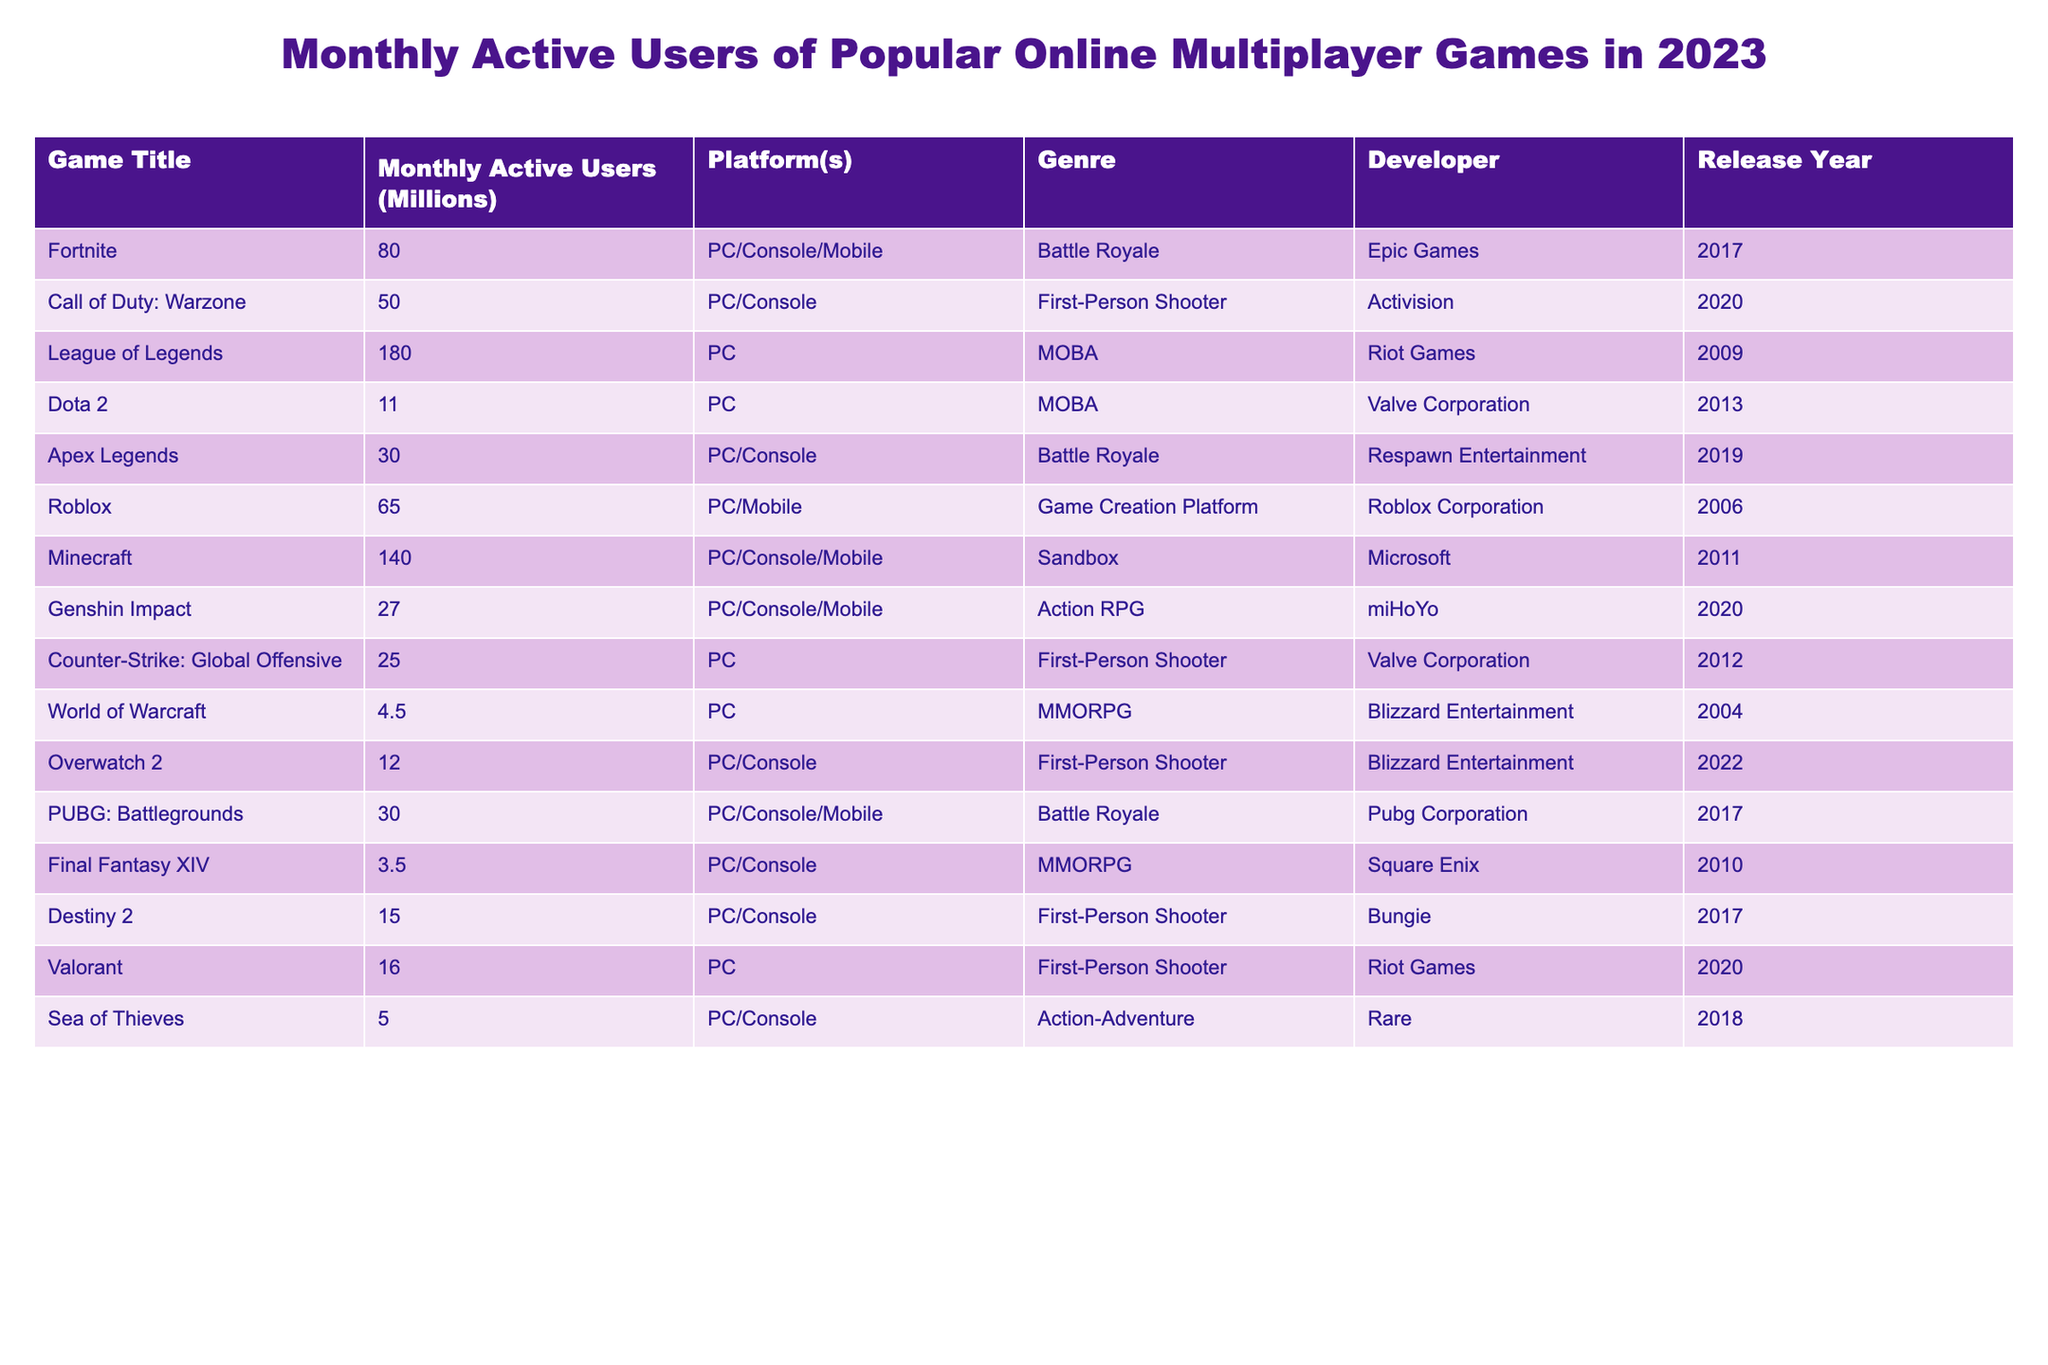What is the game with the highest monthly active users? The "League of Legends" has the highest monthly active users, with 180 million reported in the table.
Answer: League of Legends How many monthly active users does Roblox have? The table shows that Roblox has 65 million monthly active users.
Answer: 65 million What is the total number of monthly active users for Fortnite and Call of Duty: Warzone combined? Adding the monthly active users for both games: 80 million (Fortnite) + 50 million (Call of Duty: Warzone) = 130 million.
Answer: 130 million Is there a game with more than 100 million monthly active users? Yes, "League of Legends" and "Minecraft" both have over 100 million active users (180 million and 140 million respectively).
Answer: Yes Which genre has the most games listed in the table? The table does not specify the counts, but "First-Person Shooter" appears three times (Warzone, Counter-Strike: Global Offensive, Overwatch 2, and Destiny 2), making it the most common genre.
Answer: First-Person Shooter What is the average number of monthly active users for the Battle Royale games listed? The Battle Royale games in the table are Fortnite (80 million), Apex Legends (30 million), and PUBG: Battlegrounds (30 million). The average is calculated as (80 + 30 + 30) / 3 = 46.67 million.
Answer: 46.67 million How many more users does Minecraft have than Dota 2? Minecraft has 140 million users, while Dota 2 has 11 million. The difference is 140 - 11 = 129 million.
Answer: 129 million Are there more Action RPGs or MOBA games listed? The table shows 2 Action RPGs (Genshin Impact) and 2 MOBA (League of Legends and Dota 2). They are equal in number, thus there is no genre with more titles.
Answer: Equal What percentage of monthly active users does Overwatch 2 represent compared to League of Legends? Overwatch 2 has 12 million users, whereas League of Legends has 180 million. The percentage is (12 / 180) * 100 = 6.67%.
Answer: 6.67% Which developer has the most games listed in the table? The developers in the table include Activision, Riot Games, Epic Games, Valve Corporation (4 games), and Blizzard Entertainment (2). Valve Corporation has the most games listed with 4.
Answer: Valve Corporation 